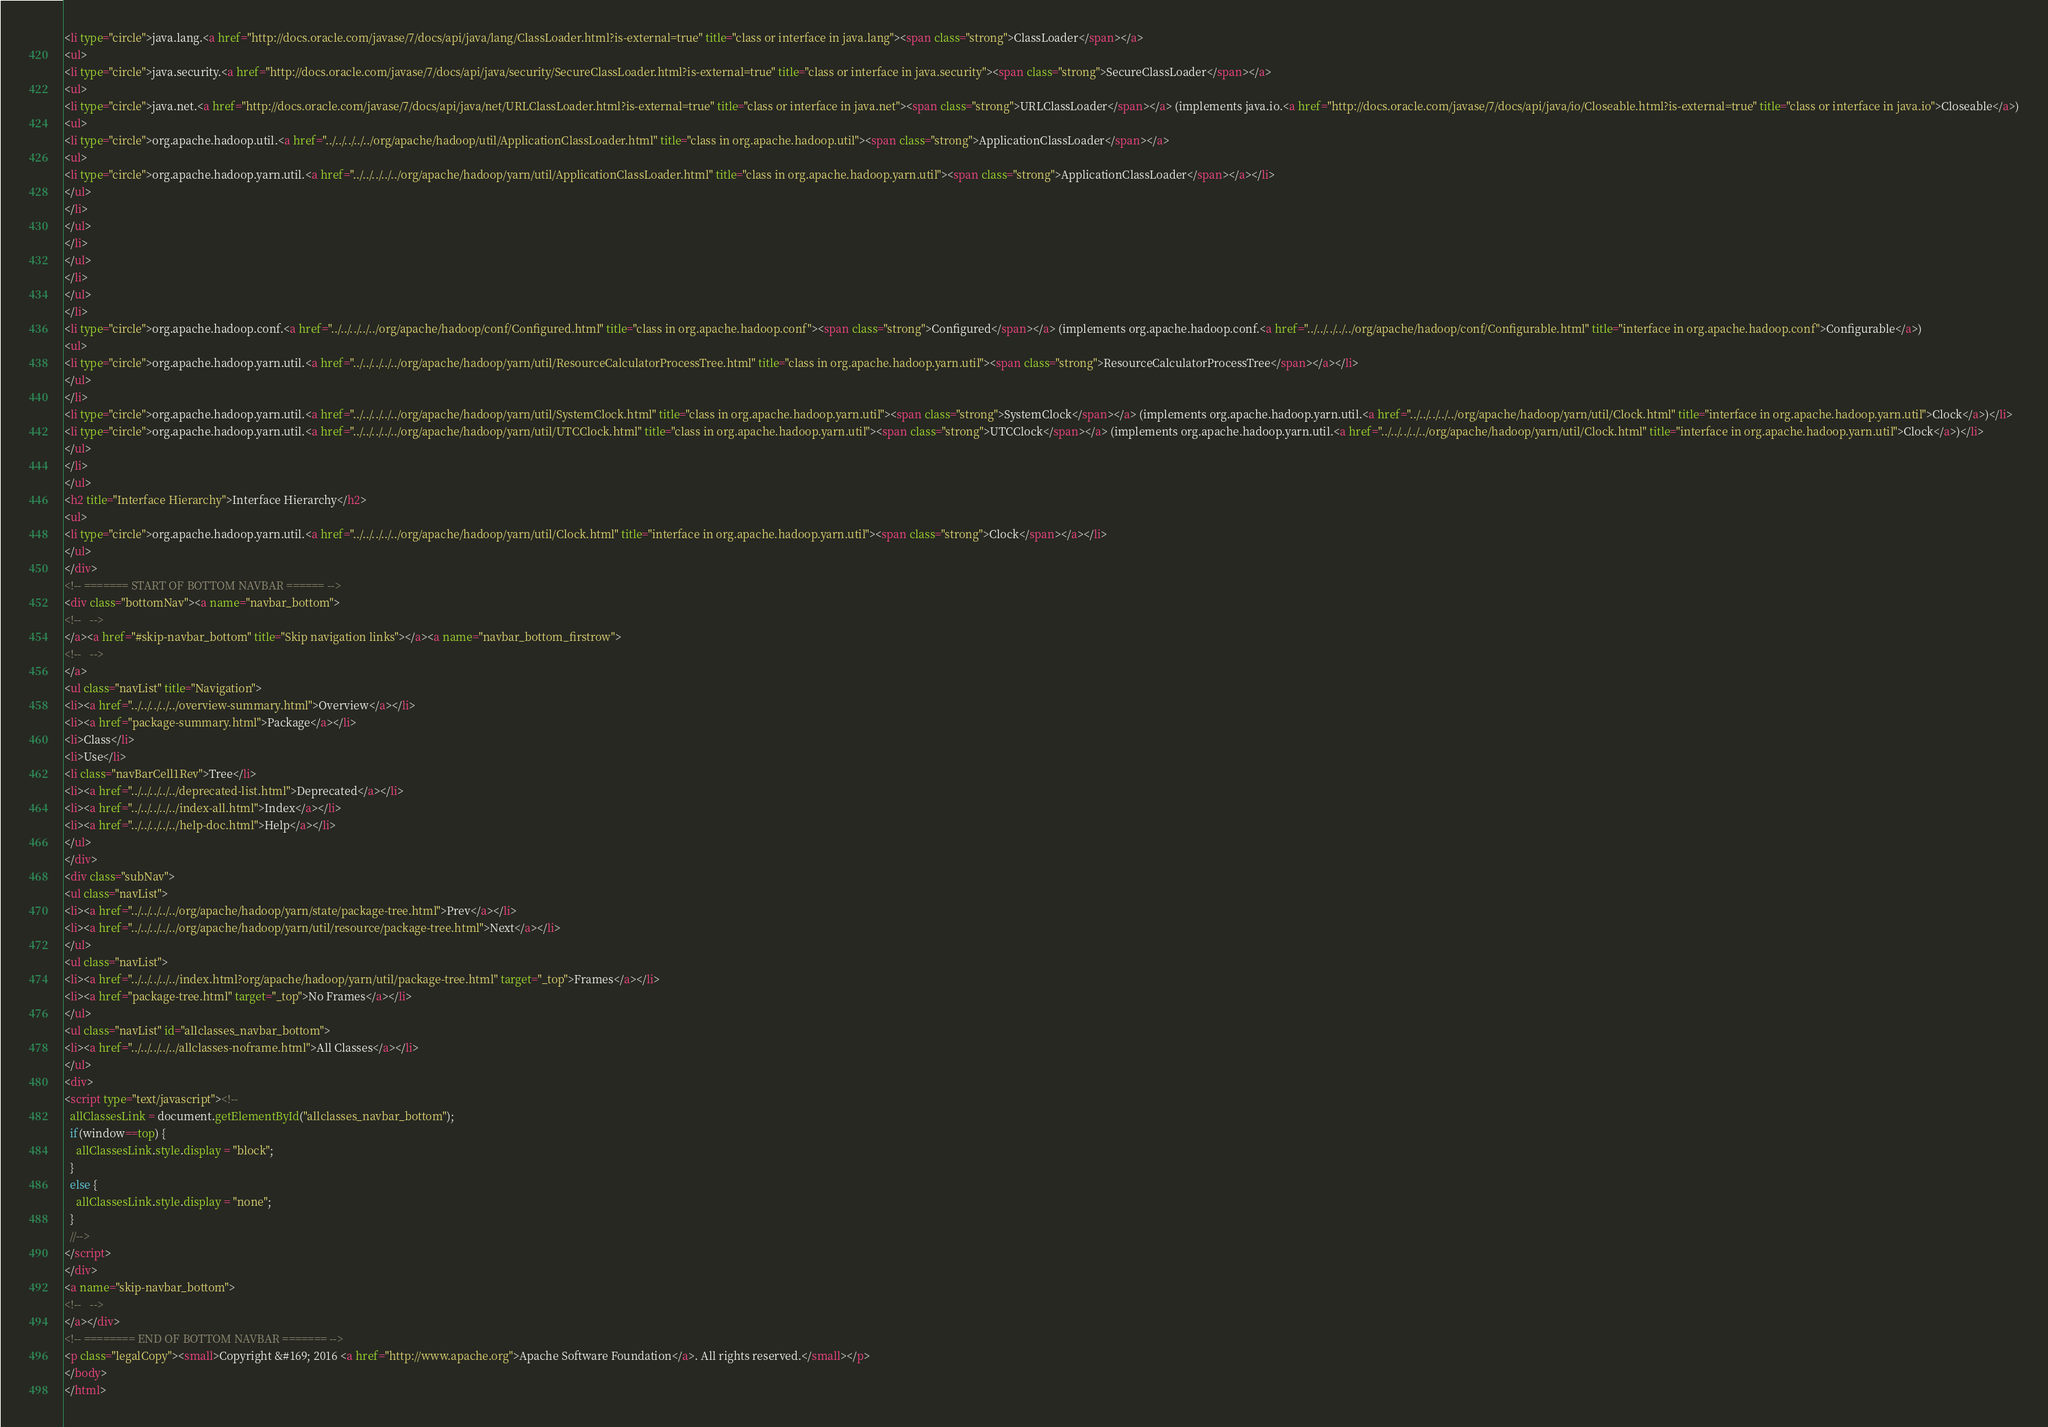Convert code to text. <code><loc_0><loc_0><loc_500><loc_500><_HTML_><li type="circle">java.lang.<a href="http://docs.oracle.com/javase/7/docs/api/java/lang/ClassLoader.html?is-external=true" title="class or interface in java.lang"><span class="strong">ClassLoader</span></a>
<ul>
<li type="circle">java.security.<a href="http://docs.oracle.com/javase/7/docs/api/java/security/SecureClassLoader.html?is-external=true" title="class or interface in java.security"><span class="strong">SecureClassLoader</span></a>
<ul>
<li type="circle">java.net.<a href="http://docs.oracle.com/javase/7/docs/api/java/net/URLClassLoader.html?is-external=true" title="class or interface in java.net"><span class="strong">URLClassLoader</span></a> (implements java.io.<a href="http://docs.oracle.com/javase/7/docs/api/java/io/Closeable.html?is-external=true" title="class or interface in java.io">Closeable</a>)
<ul>
<li type="circle">org.apache.hadoop.util.<a href="../../../../../org/apache/hadoop/util/ApplicationClassLoader.html" title="class in org.apache.hadoop.util"><span class="strong">ApplicationClassLoader</span></a>
<ul>
<li type="circle">org.apache.hadoop.yarn.util.<a href="../../../../../org/apache/hadoop/yarn/util/ApplicationClassLoader.html" title="class in org.apache.hadoop.yarn.util"><span class="strong">ApplicationClassLoader</span></a></li>
</ul>
</li>
</ul>
</li>
</ul>
</li>
</ul>
</li>
<li type="circle">org.apache.hadoop.conf.<a href="../../../../../org/apache/hadoop/conf/Configured.html" title="class in org.apache.hadoop.conf"><span class="strong">Configured</span></a> (implements org.apache.hadoop.conf.<a href="../../../../../org/apache/hadoop/conf/Configurable.html" title="interface in org.apache.hadoop.conf">Configurable</a>)
<ul>
<li type="circle">org.apache.hadoop.yarn.util.<a href="../../../../../org/apache/hadoop/yarn/util/ResourceCalculatorProcessTree.html" title="class in org.apache.hadoop.yarn.util"><span class="strong">ResourceCalculatorProcessTree</span></a></li>
</ul>
</li>
<li type="circle">org.apache.hadoop.yarn.util.<a href="../../../../../org/apache/hadoop/yarn/util/SystemClock.html" title="class in org.apache.hadoop.yarn.util"><span class="strong">SystemClock</span></a> (implements org.apache.hadoop.yarn.util.<a href="../../../../../org/apache/hadoop/yarn/util/Clock.html" title="interface in org.apache.hadoop.yarn.util">Clock</a>)</li>
<li type="circle">org.apache.hadoop.yarn.util.<a href="../../../../../org/apache/hadoop/yarn/util/UTCClock.html" title="class in org.apache.hadoop.yarn.util"><span class="strong">UTCClock</span></a> (implements org.apache.hadoop.yarn.util.<a href="../../../../../org/apache/hadoop/yarn/util/Clock.html" title="interface in org.apache.hadoop.yarn.util">Clock</a>)</li>
</ul>
</li>
</ul>
<h2 title="Interface Hierarchy">Interface Hierarchy</h2>
<ul>
<li type="circle">org.apache.hadoop.yarn.util.<a href="../../../../../org/apache/hadoop/yarn/util/Clock.html" title="interface in org.apache.hadoop.yarn.util"><span class="strong">Clock</span></a></li>
</ul>
</div>
<!-- ======= START OF BOTTOM NAVBAR ====== -->
<div class="bottomNav"><a name="navbar_bottom">
<!--   -->
</a><a href="#skip-navbar_bottom" title="Skip navigation links"></a><a name="navbar_bottom_firstrow">
<!--   -->
</a>
<ul class="navList" title="Navigation">
<li><a href="../../../../../overview-summary.html">Overview</a></li>
<li><a href="package-summary.html">Package</a></li>
<li>Class</li>
<li>Use</li>
<li class="navBarCell1Rev">Tree</li>
<li><a href="../../../../../deprecated-list.html">Deprecated</a></li>
<li><a href="../../../../../index-all.html">Index</a></li>
<li><a href="../../../../../help-doc.html">Help</a></li>
</ul>
</div>
<div class="subNav">
<ul class="navList">
<li><a href="../../../../../org/apache/hadoop/yarn/state/package-tree.html">Prev</a></li>
<li><a href="../../../../../org/apache/hadoop/yarn/util/resource/package-tree.html">Next</a></li>
</ul>
<ul class="navList">
<li><a href="../../../../../index.html?org/apache/hadoop/yarn/util/package-tree.html" target="_top">Frames</a></li>
<li><a href="package-tree.html" target="_top">No Frames</a></li>
</ul>
<ul class="navList" id="allclasses_navbar_bottom">
<li><a href="../../../../../allclasses-noframe.html">All Classes</a></li>
</ul>
<div>
<script type="text/javascript"><!--
  allClassesLink = document.getElementById("allclasses_navbar_bottom");
  if(window==top) {
    allClassesLink.style.display = "block";
  }
  else {
    allClassesLink.style.display = "none";
  }
  //-->
</script>
</div>
<a name="skip-navbar_bottom">
<!--   -->
</a></div>
<!-- ======== END OF BOTTOM NAVBAR ======= -->
<p class="legalCopy"><small>Copyright &#169; 2016 <a href="http://www.apache.org">Apache Software Foundation</a>. All rights reserved.</small></p>
</body>
</html>
</code> 